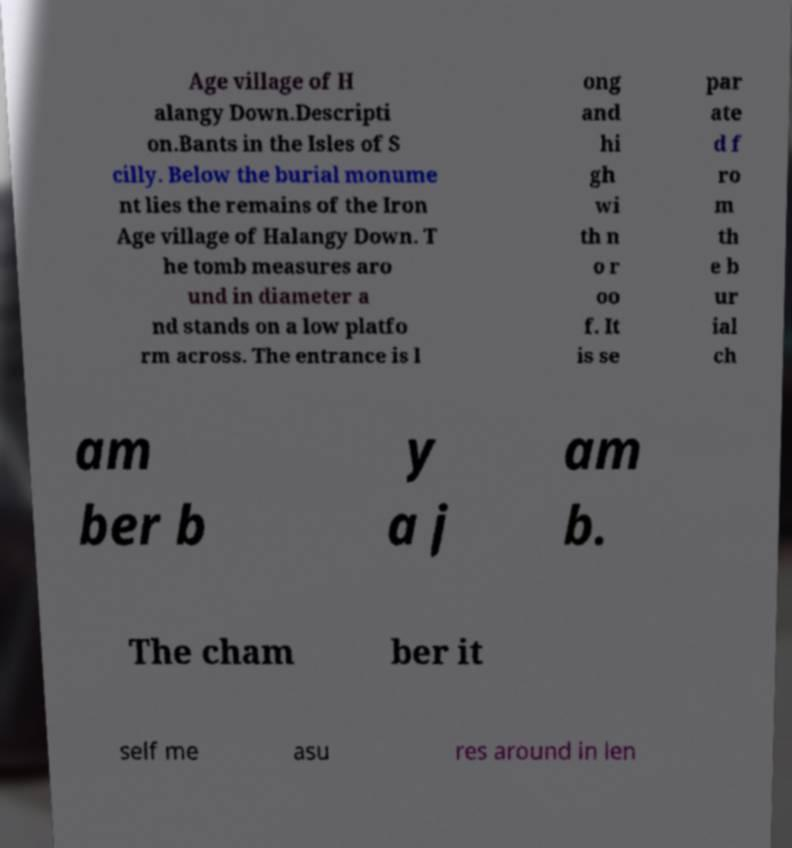For documentation purposes, I need the text within this image transcribed. Could you provide that? Age village of H alangy Down.Descripti on.Bants in the Isles of S cilly. Below the burial monume nt lies the remains of the Iron Age village of Halangy Down. T he tomb measures aro und in diameter a nd stands on a low platfo rm across. The entrance is l ong and hi gh wi th n o r oo f. It is se par ate d f ro m th e b ur ial ch am ber b y a j am b. The cham ber it self me asu res around in len 